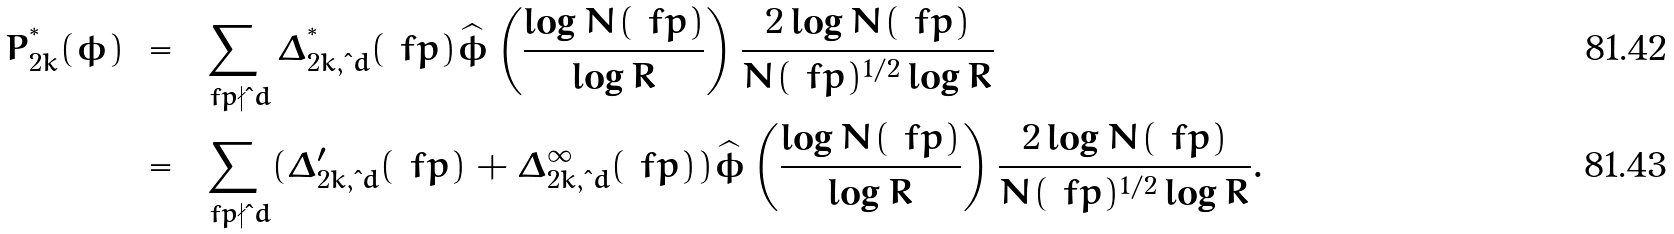<formula> <loc_0><loc_0><loc_500><loc_500>P _ { 2 k } ^ { ^ { * } } ( \phi ) & \ = \ \sum _ { \ f p \nmid \i d } \Delta _ { 2 k , \i d } ^ { ^ { * } } ( \ f p ) \widehat { \phi } \left ( \frac { \log N ( \ f p ) } { \log R } \right ) \frac { 2 \log N ( \ f p ) } { N ( \ f p ) ^ { 1 / 2 } \log R } \\ & \ = \ \sum _ { \ f p \nmid \i d } ( \Delta _ { 2 k , \i d } ^ { \prime } ( \ f p ) + \Delta _ { 2 k , \i d } ^ { \infty } ( \ f p ) ) \widehat { \phi } \left ( \frac { \log N ( \ f p ) } { \log R } \right ) \frac { 2 \log N ( \ f p ) } { N ( \ f p ) ^ { 1 / 2 } \log R } .</formula> 